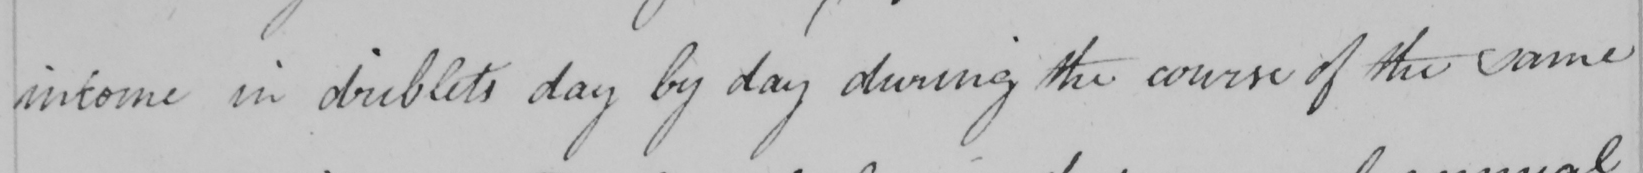Can you tell me what this handwritten text says? income in driblets day by day during the course of the same 